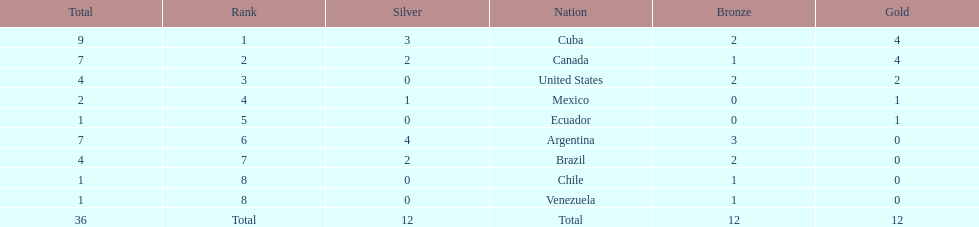How many total medals were there all together? 36. 